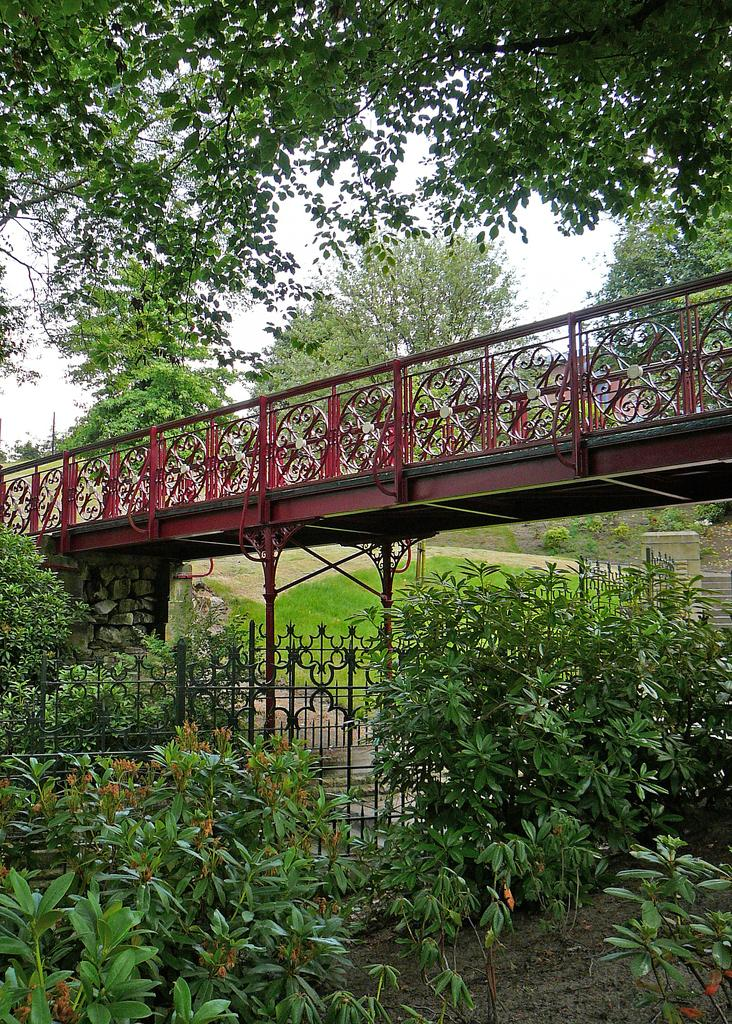What type of vegetation can be seen in the image? There are trees in the image. What type of area is depicted in the image? There is a garden in the image. What architectural feature is present in the image? There is a small bridge in the image. What type of truck can be seen driving through the garden in the image? There is no truck present in the image; it only features trees, a garden, and a small bridge. What type of team is playing in the garden in the image? There is no team present in the image; it only features trees, a garden, and a small bridge. 